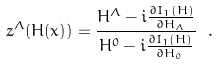<formula> <loc_0><loc_0><loc_500><loc_500>z ^ { \Lambda } ( H ( x ) ) = \frac { H ^ { \Lambda } - i \frac { \partial I _ { 1 } ( H ) } { \partial H _ { \Lambda } } } { H ^ { 0 } - i \frac { \partial I _ { 1 } ( H ) } { \partial H _ { 0 } } } \ .</formula> 